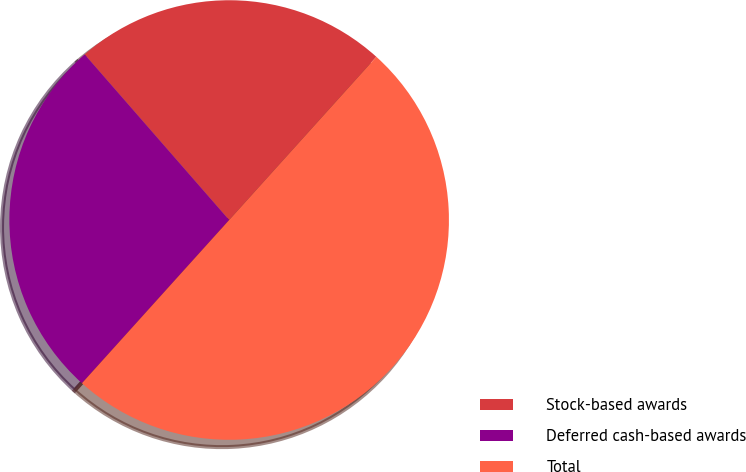Convert chart to OTSL. <chart><loc_0><loc_0><loc_500><loc_500><pie_chart><fcel>Stock-based awards<fcel>Deferred cash-based awards<fcel>Total<nl><fcel>23.1%<fcel>26.9%<fcel>50.0%<nl></chart> 